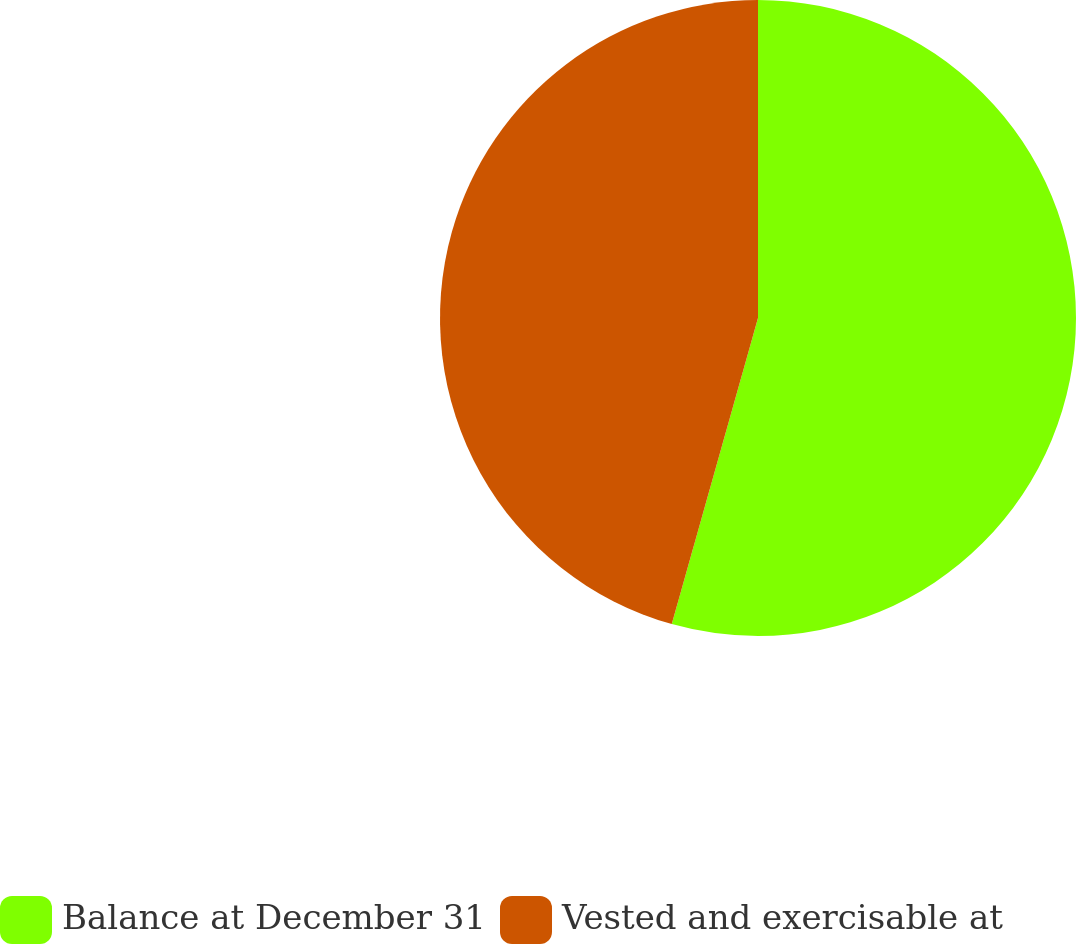Convert chart. <chart><loc_0><loc_0><loc_500><loc_500><pie_chart><fcel>Balance at December 31<fcel>Vested and exercisable at<nl><fcel>54.37%<fcel>45.63%<nl></chart> 